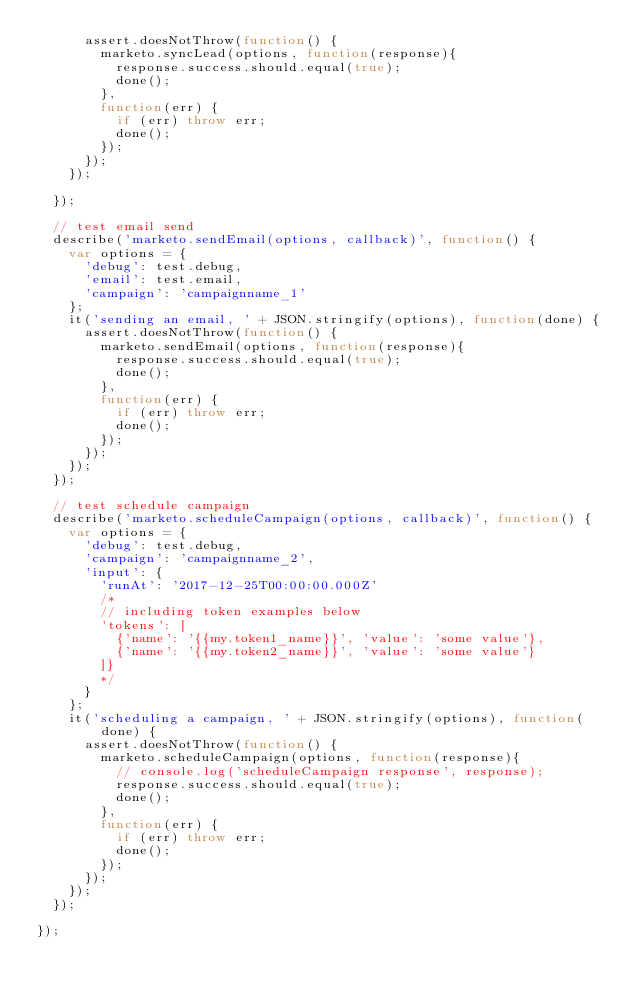Convert code to text. <code><loc_0><loc_0><loc_500><loc_500><_JavaScript_>      assert.doesNotThrow(function() {
        marketo.syncLead(options, function(response){
          response.success.should.equal(true);
          done();
        }, 
        function(err) {
          if (err) throw err; 
          done(); 
        });
      });
    });

  });

  // test email send
  describe('marketo.sendEmail(options, callback)', function() {
    var options = {
      'debug': test.debug,
      'email': test.email, 
      'campaign': 'campaignname_1'
    };
    it('sending an email, ' + JSON.stringify(options), function(done) {
      assert.doesNotThrow(function() {
        marketo.sendEmail(options, function(response){
          response.success.should.equal(true);
          done();
        }, 
        function(err) {
          if (err) throw err; 
          done(); 
        });
      });
    });
  });  

  // test schedule campaign
  describe('marketo.scheduleCampaign(options, callback)', function() {
    var options = {
      'debug': test.debug,
      'campaign': 'campaignname_2',
      'input': {
        'runAt': '2017-12-25T00:00:00.000Z'
        /*
        // including token examples below
        'tokens': [
          {'name': '{{my.token1_name}}', 'value': 'some value'},
          {'name': '{{my.token2_name}}', 'value': 'some value'}
        ]}
        */
      }
    };
    it('scheduling a campaign, ' + JSON.stringify(options), function(done) {
      assert.doesNotThrow(function() {
        marketo.scheduleCampaign(options, function(response){
          // console.log('scheduleCampaign response', response);
          response.success.should.equal(true);
          done();
        }, 
        function(err) {
          if (err) throw err; 
          done(); 
        });
      });
    });
  });

});

</code> 